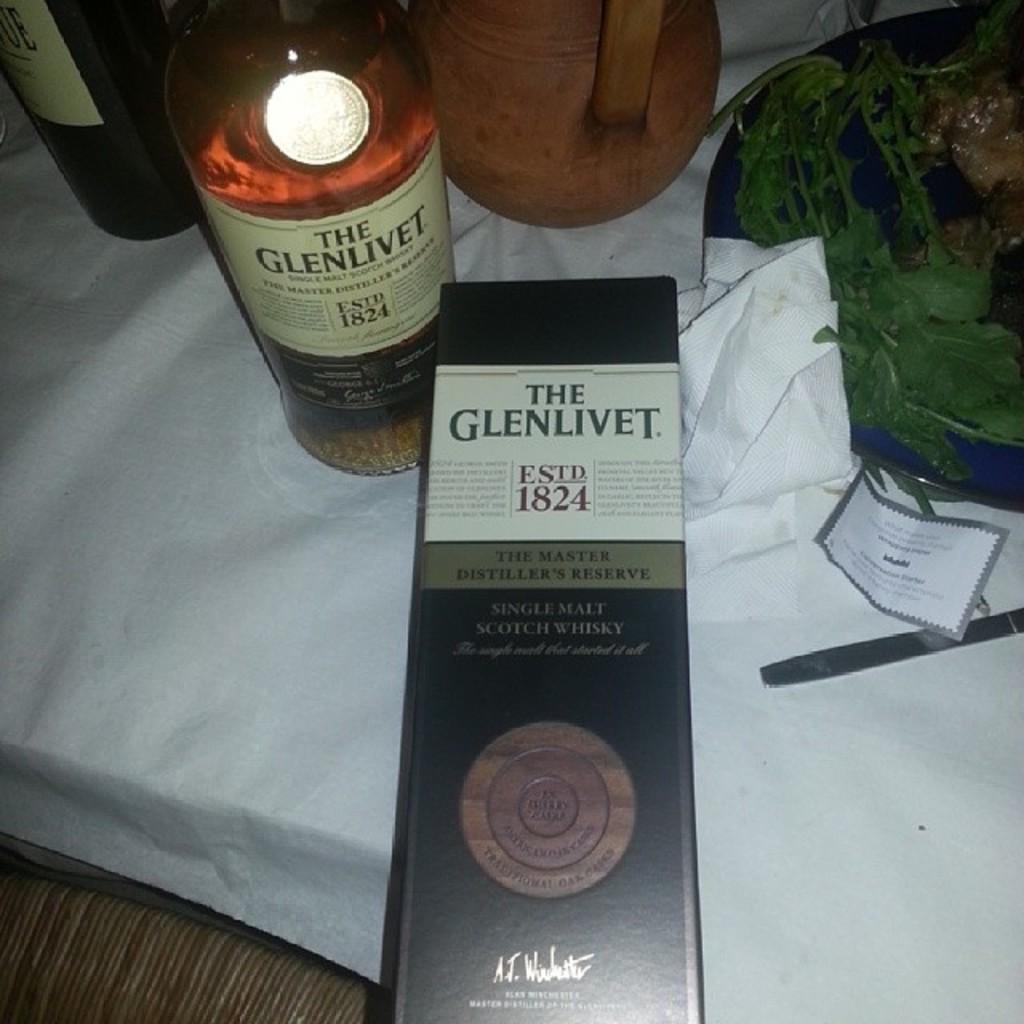When was the glenlivet established?
Your response must be concise. 1824. What type of scotch whiskey in this?
Ensure brevity in your answer.  The glenlivet. 